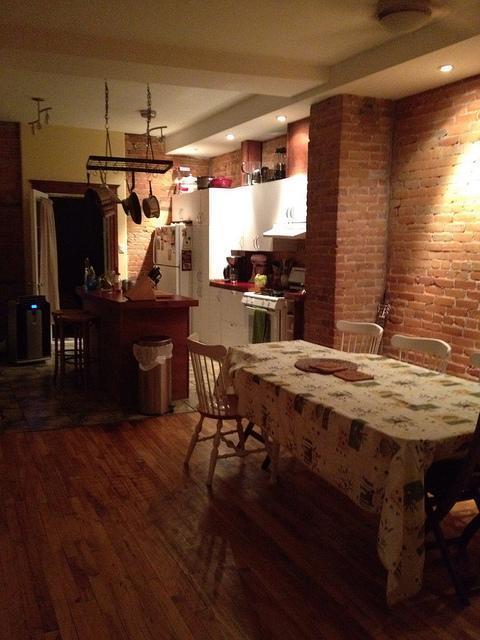What is next to the chair?
Indicate the correct response and explain using: 'Answer: answer
Rationale: rationale.'
Options: Pumpkin, apple pie, tablecloth, baby. Answer: tablecloth.
Rationale: A tablecloth is next to the chair. the tablecloth covers the actual table. 